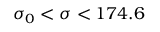<formula> <loc_0><loc_0><loc_500><loc_500>\sigma _ { 0 } < \sigma < 1 7 4 . 6</formula> 